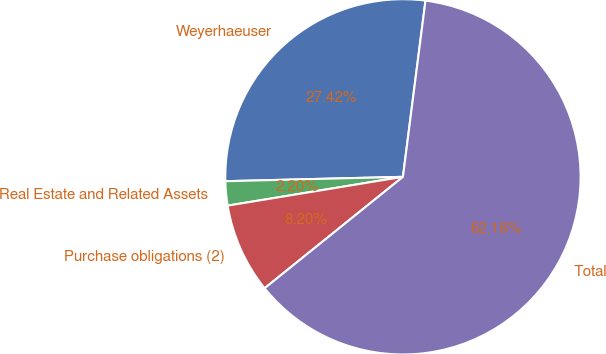Convert chart to OTSL. <chart><loc_0><loc_0><loc_500><loc_500><pie_chart><fcel>Weyerhaeuser<fcel>Real Estate and Related Assets<fcel>Purchase obligations (2)<fcel>Total<nl><fcel>27.42%<fcel>2.2%<fcel>8.2%<fcel>62.19%<nl></chart> 